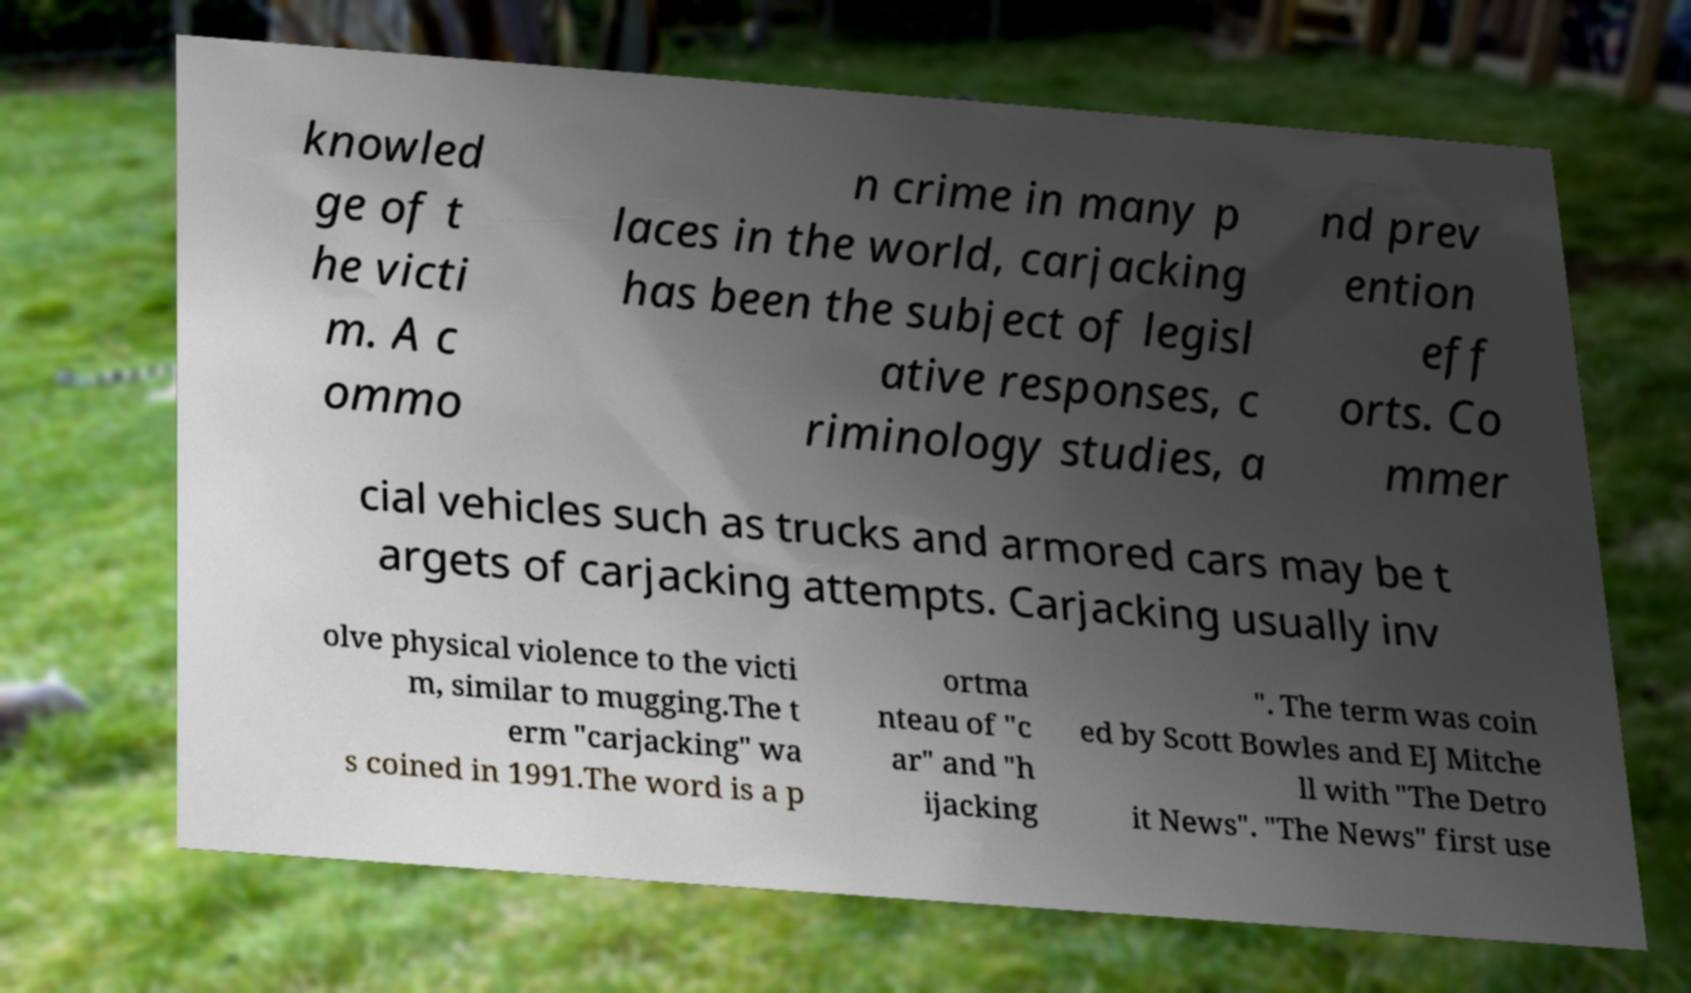There's text embedded in this image that I need extracted. Can you transcribe it verbatim? knowled ge of t he victi m. A c ommo n crime in many p laces in the world, carjacking has been the subject of legisl ative responses, c riminology studies, a nd prev ention eff orts. Co mmer cial vehicles such as trucks and armored cars may be t argets of carjacking attempts. Carjacking usually inv olve physical violence to the victi m, similar to mugging.The t erm "carjacking" wa s coined in 1991.The word is a p ortma nteau of "c ar" and "h ijacking ". The term was coin ed by Scott Bowles and EJ Mitche ll with "The Detro it News". "The News" first use 